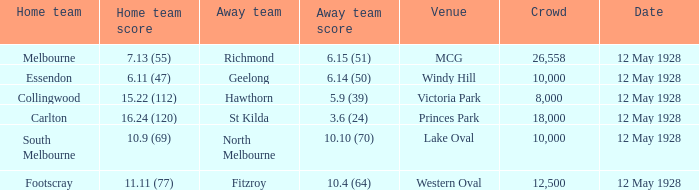Write the full table. {'header': ['Home team', 'Home team score', 'Away team', 'Away team score', 'Venue', 'Crowd', 'Date'], 'rows': [['Melbourne', '7.13 (55)', 'Richmond', '6.15 (51)', 'MCG', '26,558', '12 May 1928'], ['Essendon', '6.11 (47)', 'Geelong', '6.14 (50)', 'Windy Hill', '10,000', '12 May 1928'], ['Collingwood', '15.22 (112)', 'Hawthorn', '5.9 (39)', 'Victoria Park', '8,000', '12 May 1928'], ['Carlton', '16.24 (120)', 'St Kilda', '3.6 (24)', 'Princes Park', '18,000', '12 May 1928'], ['South Melbourne', '10.9 (69)', 'North Melbourne', '10.10 (70)', 'Lake Oval', '10,000', '12 May 1928'], ['Footscray', '11.11 (77)', 'Fitzroy', '10.4 (64)', 'Western Oval', '12,500', '12 May 1928']]} Who is the away side when the crowd is over 18,000 with collingwood at home? None. 